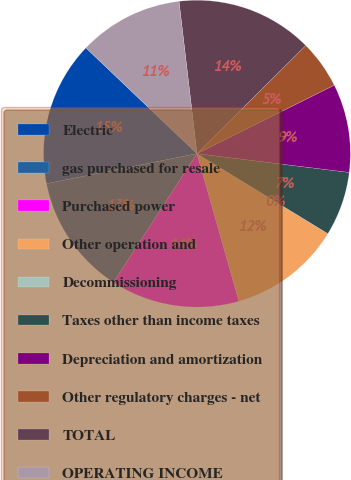<chart> <loc_0><loc_0><loc_500><loc_500><pie_chart><fcel>Electric<fcel>gas purchased for resale<fcel>Purchased power<fcel>Other operation and<fcel>Decommissioning<fcel>Taxes other than income taxes<fcel>Depreciation and amortization<fcel>Other regulatory charges - net<fcel>TOTAL<fcel>OPERATING INCOME<nl><fcel>15.25%<fcel>12.71%<fcel>13.56%<fcel>11.86%<fcel>0.0%<fcel>6.78%<fcel>9.32%<fcel>5.09%<fcel>14.41%<fcel>11.02%<nl></chart> 